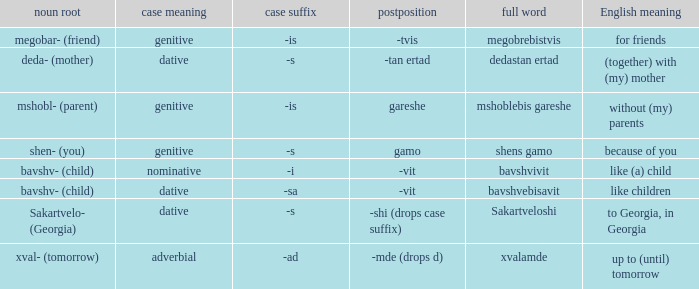What is Postposition, when Noun Root (Meaning) is "mshobl- (parent)"? Gareshe. 